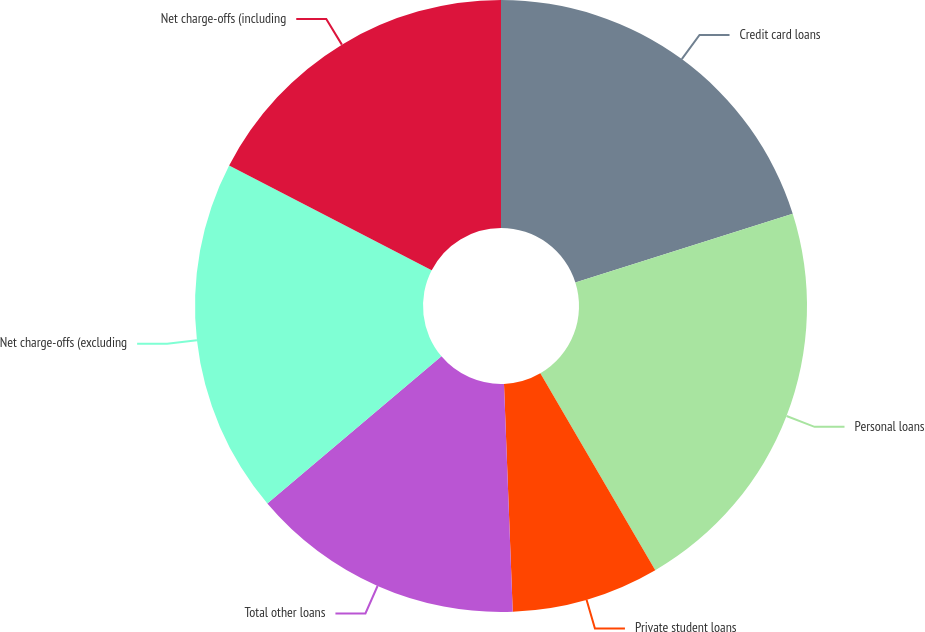Convert chart to OTSL. <chart><loc_0><loc_0><loc_500><loc_500><pie_chart><fcel>Credit card loans<fcel>Personal loans<fcel>Private student loans<fcel>Total other loans<fcel>Net charge-offs (excluding<fcel>Net charge-offs (including<nl><fcel>20.12%<fcel>21.47%<fcel>7.8%<fcel>14.44%<fcel>18.76%<fcel>17.41%<nl></chart> 